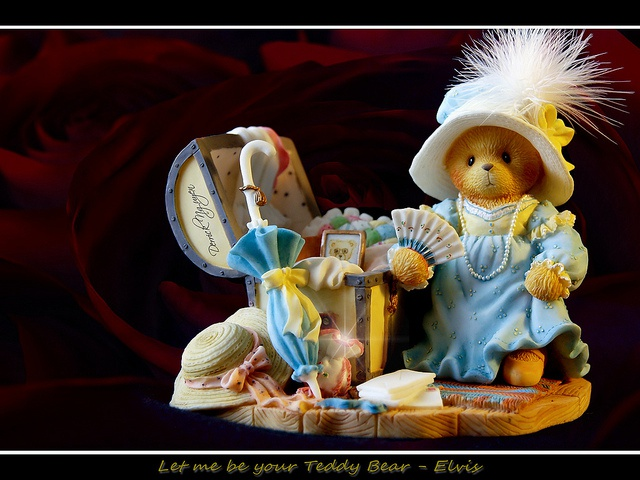Describe the objects in this image and their specific colors. I can see teddy bear in black, darkgray, lightgray, and gray tones and umbrella in black, lightgray, lightblue, and tan tones in this image. 